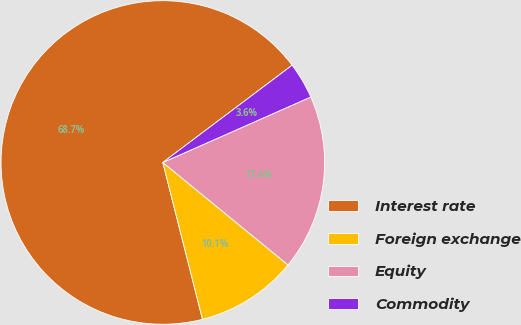Convert chart. <chart><loc_0><loc_0><loc_500><loc_500><pie_chart><fcel>Interest rate<fcel>Foreign exchange<fcel>Equity<fcel>Commodity<nl><fcel>68.68%<fcel>10.14%<fcel>17.55%<fcel>3.63%<nl></chart> 